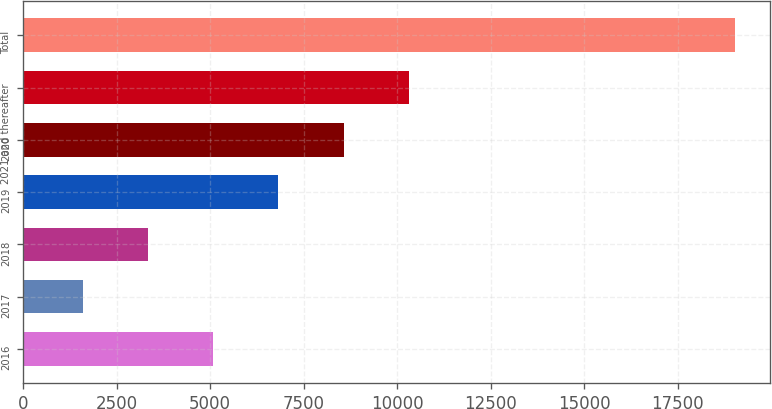<chart> <loc_0><loc_0><loc_500><loc_500><bar_chart><fcel>2016<fcel>2017<fcel>2018<fcel>2019<fcel>2020<fcel>2021 and thereafter<fcel>Total<nl><fcel>5083.8<fcel>1598<fcel>3340.9<fcel>6826.7<fcel>8569.6<fcel>10312.5<fcel>19027<nl></chart> 